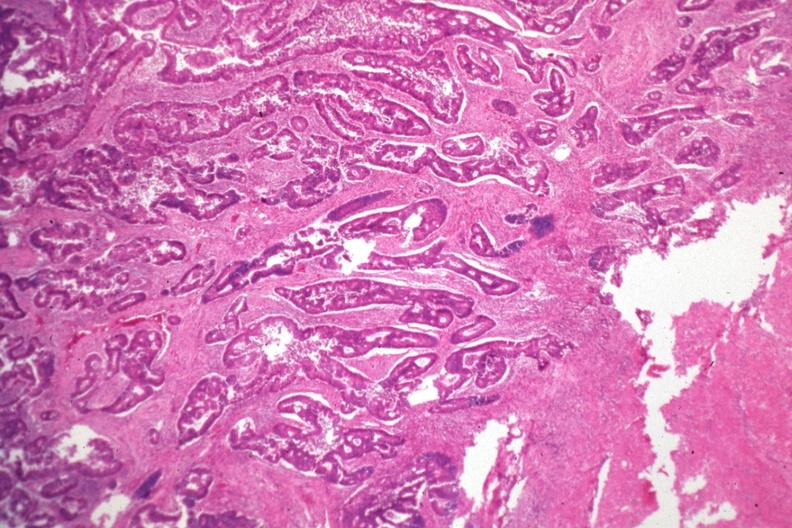does retroperitoneal leiomyosarcoma show typical infiltrating adenocarcinoma?
Answer the question using a single word or phrase. No 